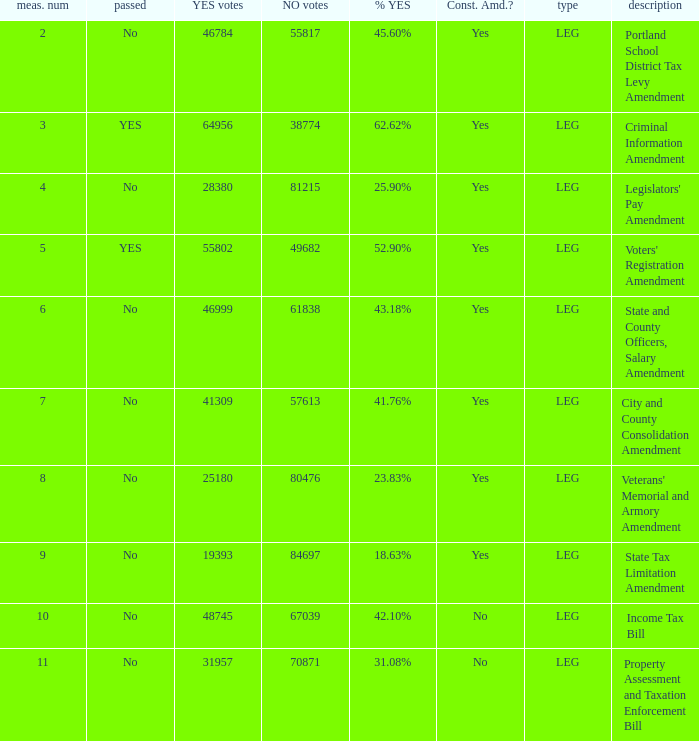18% yes? 46999.0. 